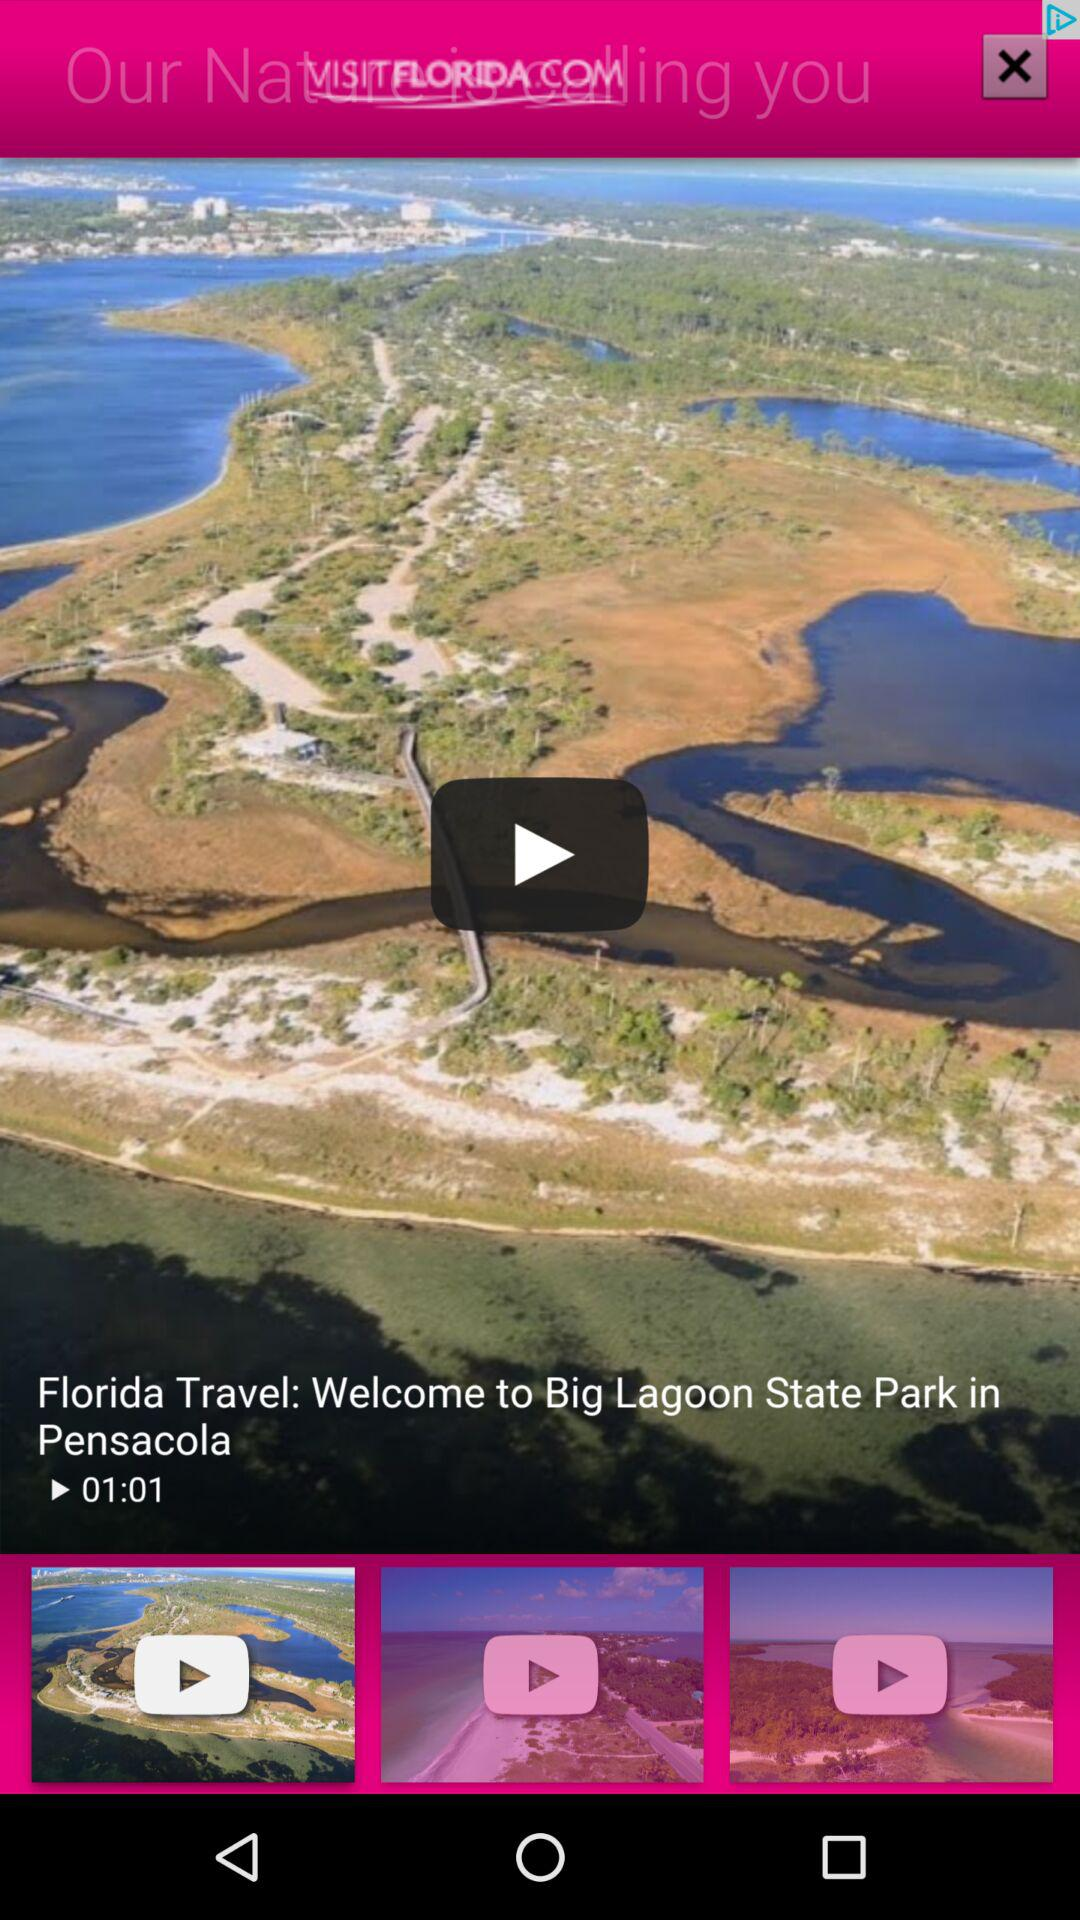What is the time duration of the video? The time duration of the video is 1 minute 1 second. 